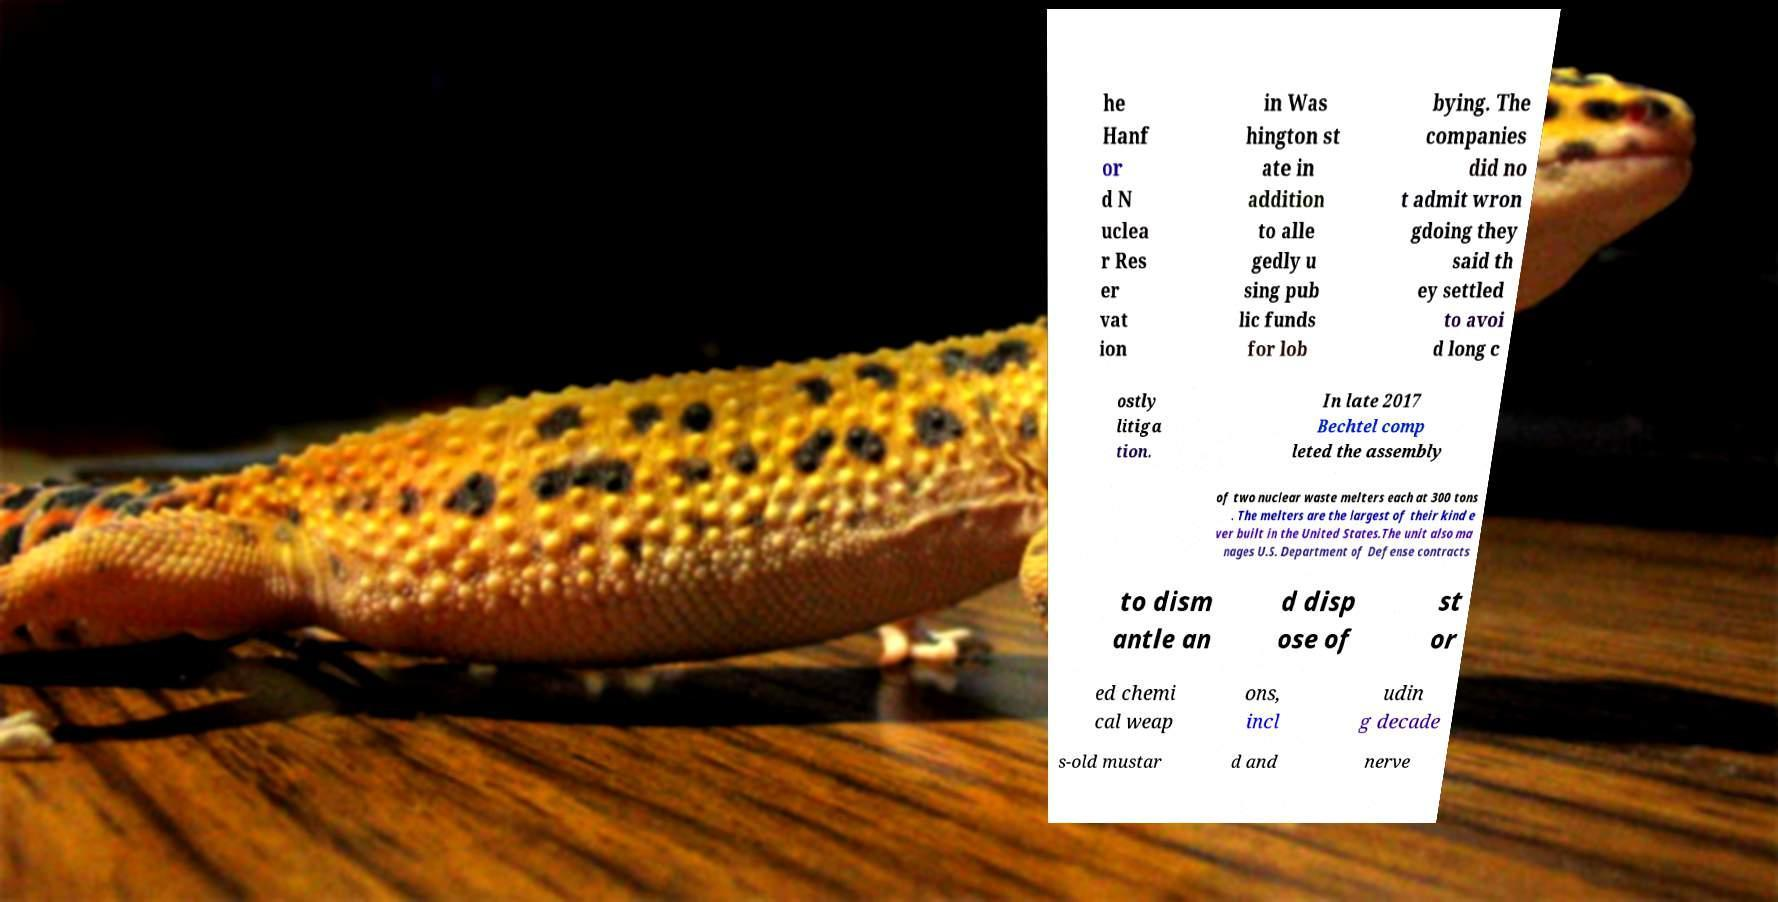Can you accurately transcribe the text from the provided image for me? he Hanf or d N uclea r Res er vat ion in Was hington st ate in addition to alle gedly u sing pub lic funds for lob bying. The companies did no t admit wron gdoing they said th ey settled to avoi d long c ostly litiga tion. In late 2017 Bechtel comp leted the assembly of two nuclear waste melters each at 300 tons . The melters are the largest of their kind e ver built in the United States.The unit also ma nages U.S. Department of Defense contracts to dism antle an d disp ose of st or ed chemi cal weap ons, incl udin g decade s-old mustar d and nerve 